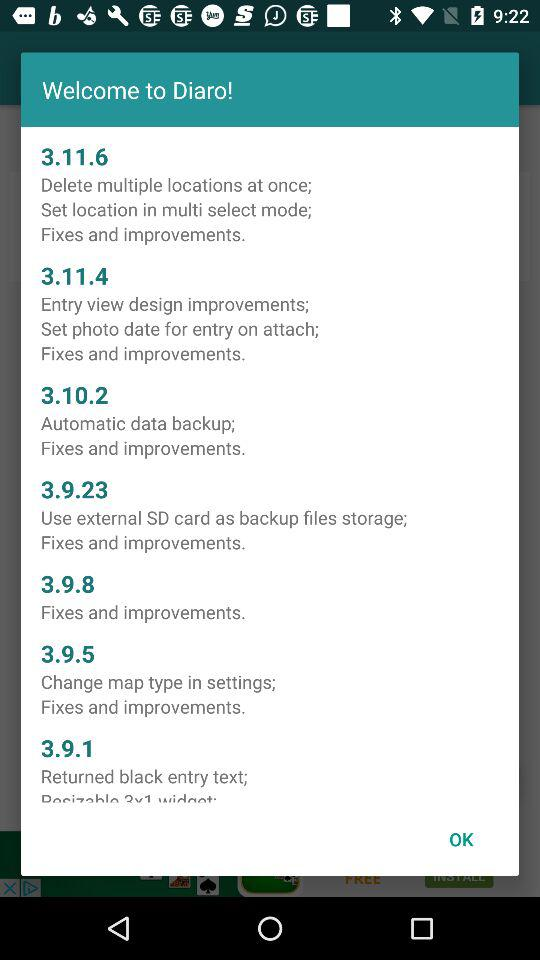In which version are there fixes and improvements? There are fixes and improvements in the 3.11.6, 3.11.4, 3.10.2, 3.9.23, 3.9.8 and 3.9.5 versions. 